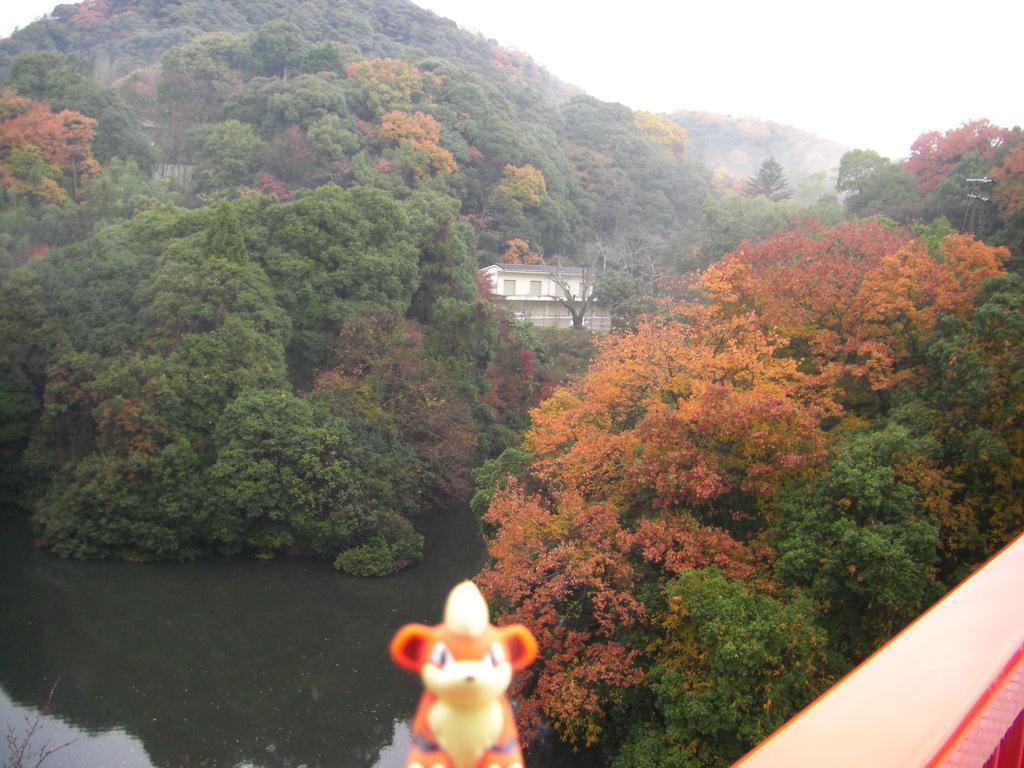Could you give a brief overview of what you see in this image? In front of the image there is a toy on the platform. In the center of the image there is a building. Around the building there are trees. There is water. On the right side of the image there is some object. At the top of the image there is sky. 